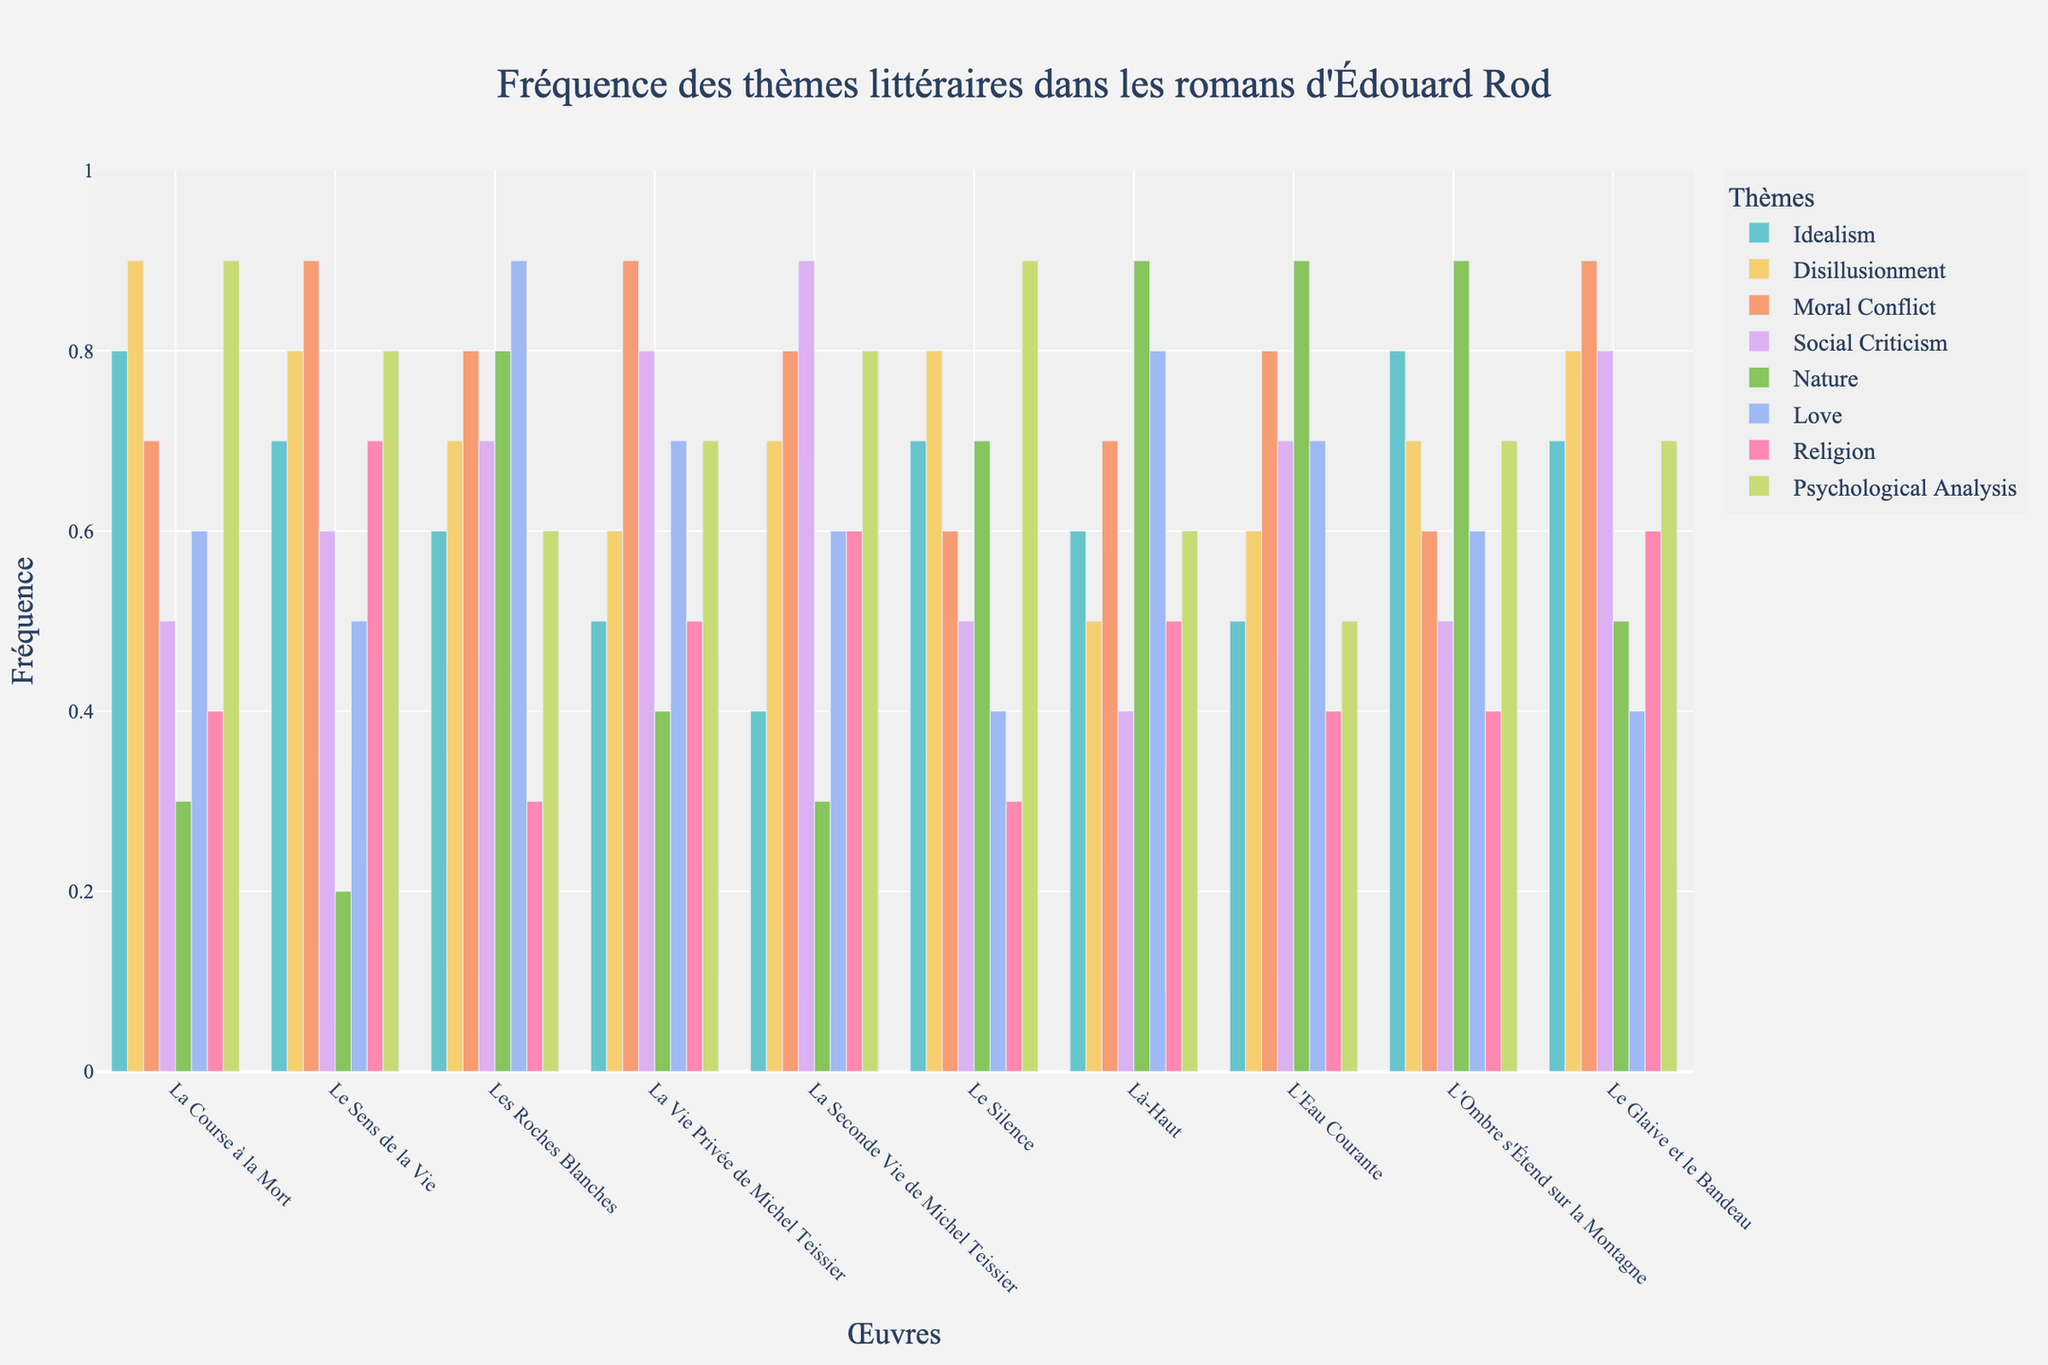What is the most frequently occurring theme in "Les Roches Blanches"? The highest bar in the group for "Les Roches Blanches" indicates the most frequent theme. By looking at the height of the bars, we can see that "Love" has the highest frequency at 0.9.
Answer: Love Which work has the lowest frequency of the "Nature" theme? Compare the heights of the "Nature" bars across all works. The shortest bar for the "Nature" theme is in "Le Sens de la Vie," where the frequency is 0.2.
Answer: Le Sens de la Vie What is the average frequency of the "Love" theme across all works? Sum the frequencies of the "Love" theme for all works and divide by the number of works (10). The frequencies are 0.6, 0.5, 0.9, 0.7, 0.6, 0.4, 0.8, 0.7, 0.6, and 0.4. The total is 6.2, and the average is 6.2 / 10 = 0.62.
Answer: 0.62 Which novel has the highest frequency of "Psychological Analysis"? Identify the highest bar in the "Psychological Analysis" category by comparing the heights across all works. "La Course à la Mort" and "Le Silence" both have the highest frequency of 0.9.
Answer: La Course à la Mort and Le Silence How does the frequency of "Moral Conflict" in "Là-Haut" compare to its frequency in "La Course à la Mort"? The bar for "Moral Conflict" in "Là-Haut" reaches a height of 0.7, while in "La Course à la Mort" it is 0.7. Therefore, they have the same frequency of 0.7.
Answer: Equal (0.7) What is the total frequency of "Idealism" across all works? Sum the frequencies of "Idealism" for all the works. The frequencies are 0.8, 0.7, 0.6, 0.5, 0.4, 0.7, 0.6, 0.5, 0.8, and 0.7. The total frequency is 0.8 + 0.7 + 0.6 + 0.5 + 0.4 + 0.7 + 0.6 + 0.5 + 0.8 + 0.7 = 6.3.
Answer: 6.3 Which work has the highest combined frequency for "Social Criticism" and "Moral Conflict"? Sum the frequencies of "Social Criticism" and "Moral Conflict" for each work and compare. "La Vie Privée de Michel Teissier" and "Le Glaive et le Bandeau" both have combined frequencies of 1.7 (0.8 + 0.9).
Answer: La Vie Privée de Michel Teissier and Le Glaive et le Bandeau 